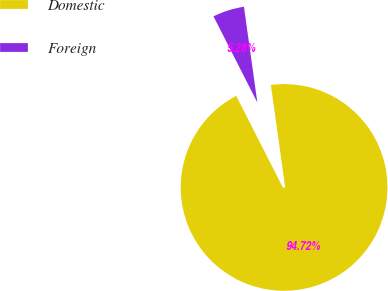Convert chart to OTSL. <chart><loc_0><loc_0><loc_500><loc_500><pie_chart><fcel>Domestic<fcel>Foreign<nl><fcel>94.72%<fcel>5.28%<nl></chart> 